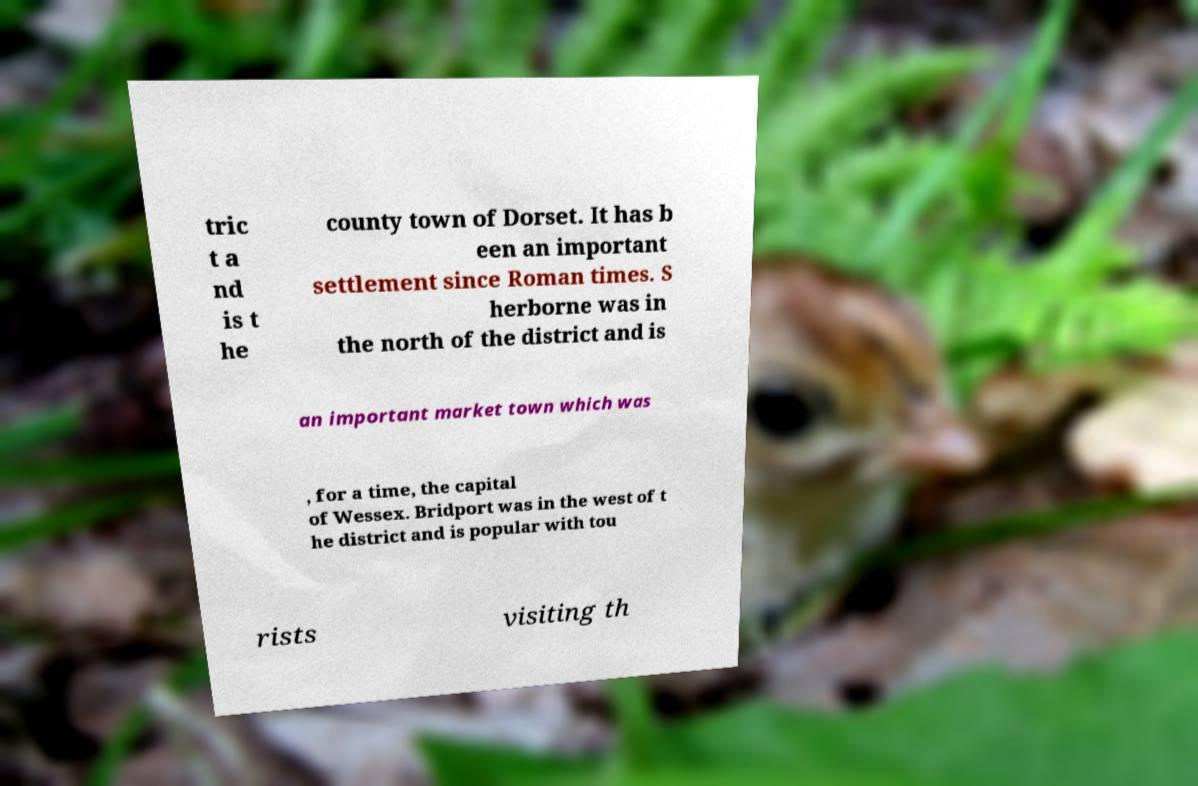For documentation purposes, I need the text within this image transcribed. Could you provide that? tric t a nd is t he county town of Dorset. It has b een an important settlement since Roman times. S herborne was in the north of the district and is an important market town which was , for a time, the capital of Wessex. Bridport was in the west of t he district and is popular with tou rists visiting th 